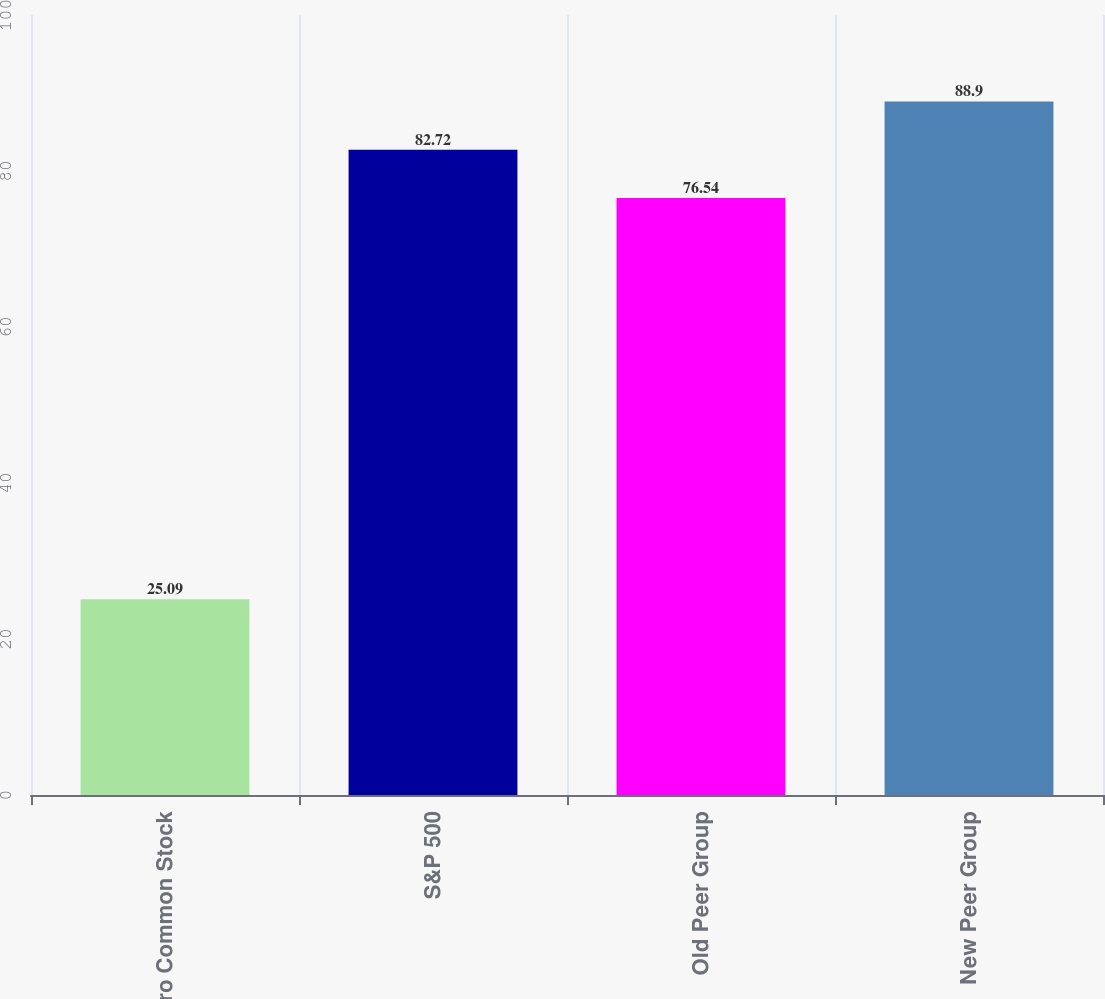Convert chart. <chart><loc_0><loc_0><loc_500><loc_500><bar_chart><fcel>Valero Common Stock<fcel>S&P 500<fcel>Old Peer Group<fcel>New Peer Group<nl><fcel>25.09<fcel>82.72<fcel>76.54<fcel>88.9<nl></chart> 